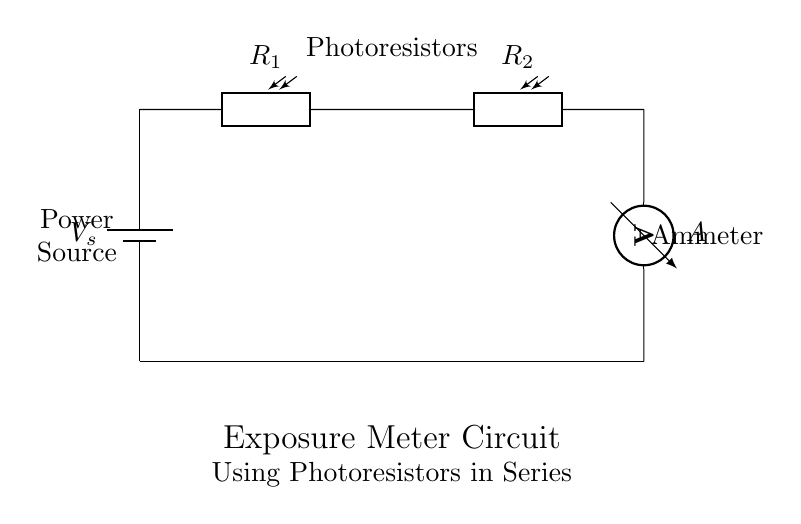What is the power source in the circuit? The power source is labeled as V_s in the diagram, which represents the voltage source for the circuit.
Answer: V_s How many photoresistors are in series? The diagram clearly shows two photoresistors connected in series, each labeled R_1 and R_2.
Answer: Two What component is used to measure current in this circuit? The ammeter is indicated in the circuit diagram as A, which is responsible for measuring the current flowing through the circuit.
Answer: A What is the function of the photoresistors in this circuit? Photoresistors change their resistance based on the light intensity, and they are used here to measure light levels, helping to provide an accurate exposure reading.
Answer: Light measurement If R_1 has twice the resistance of R_2, how does it affect the current flow? In a series circuit, the total resistance is the sum of the resistances, and if one resistor has a higher resistance, it will reduce the total current. Since R_1 is greater, the overall current decreases due to its effect on total resistance.
Answer: Current decreases What happens if one photoresistor fails in this series circuit? If one photoresistor fails, the entire circuit would break as series connections require all components to function for current to flow. Thus, the current would effectively become zero.
Answer: Circuit fails 